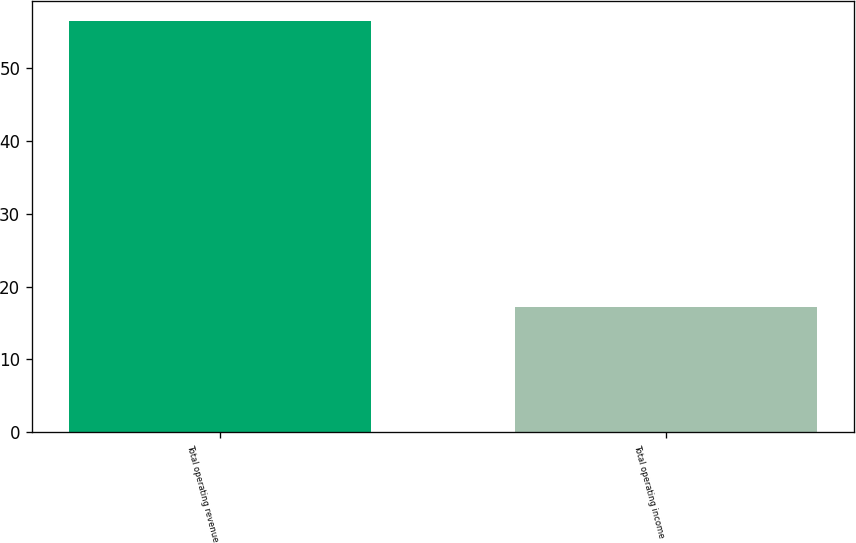Convert chart to OTSL. <chart><loc_0><loc_0><loc_500><loc_500><bar_chart><fcel>Total operating revenue<fcel>Total operating income<nl><fcel>56.5<fcel>17.2<nl></chart> 